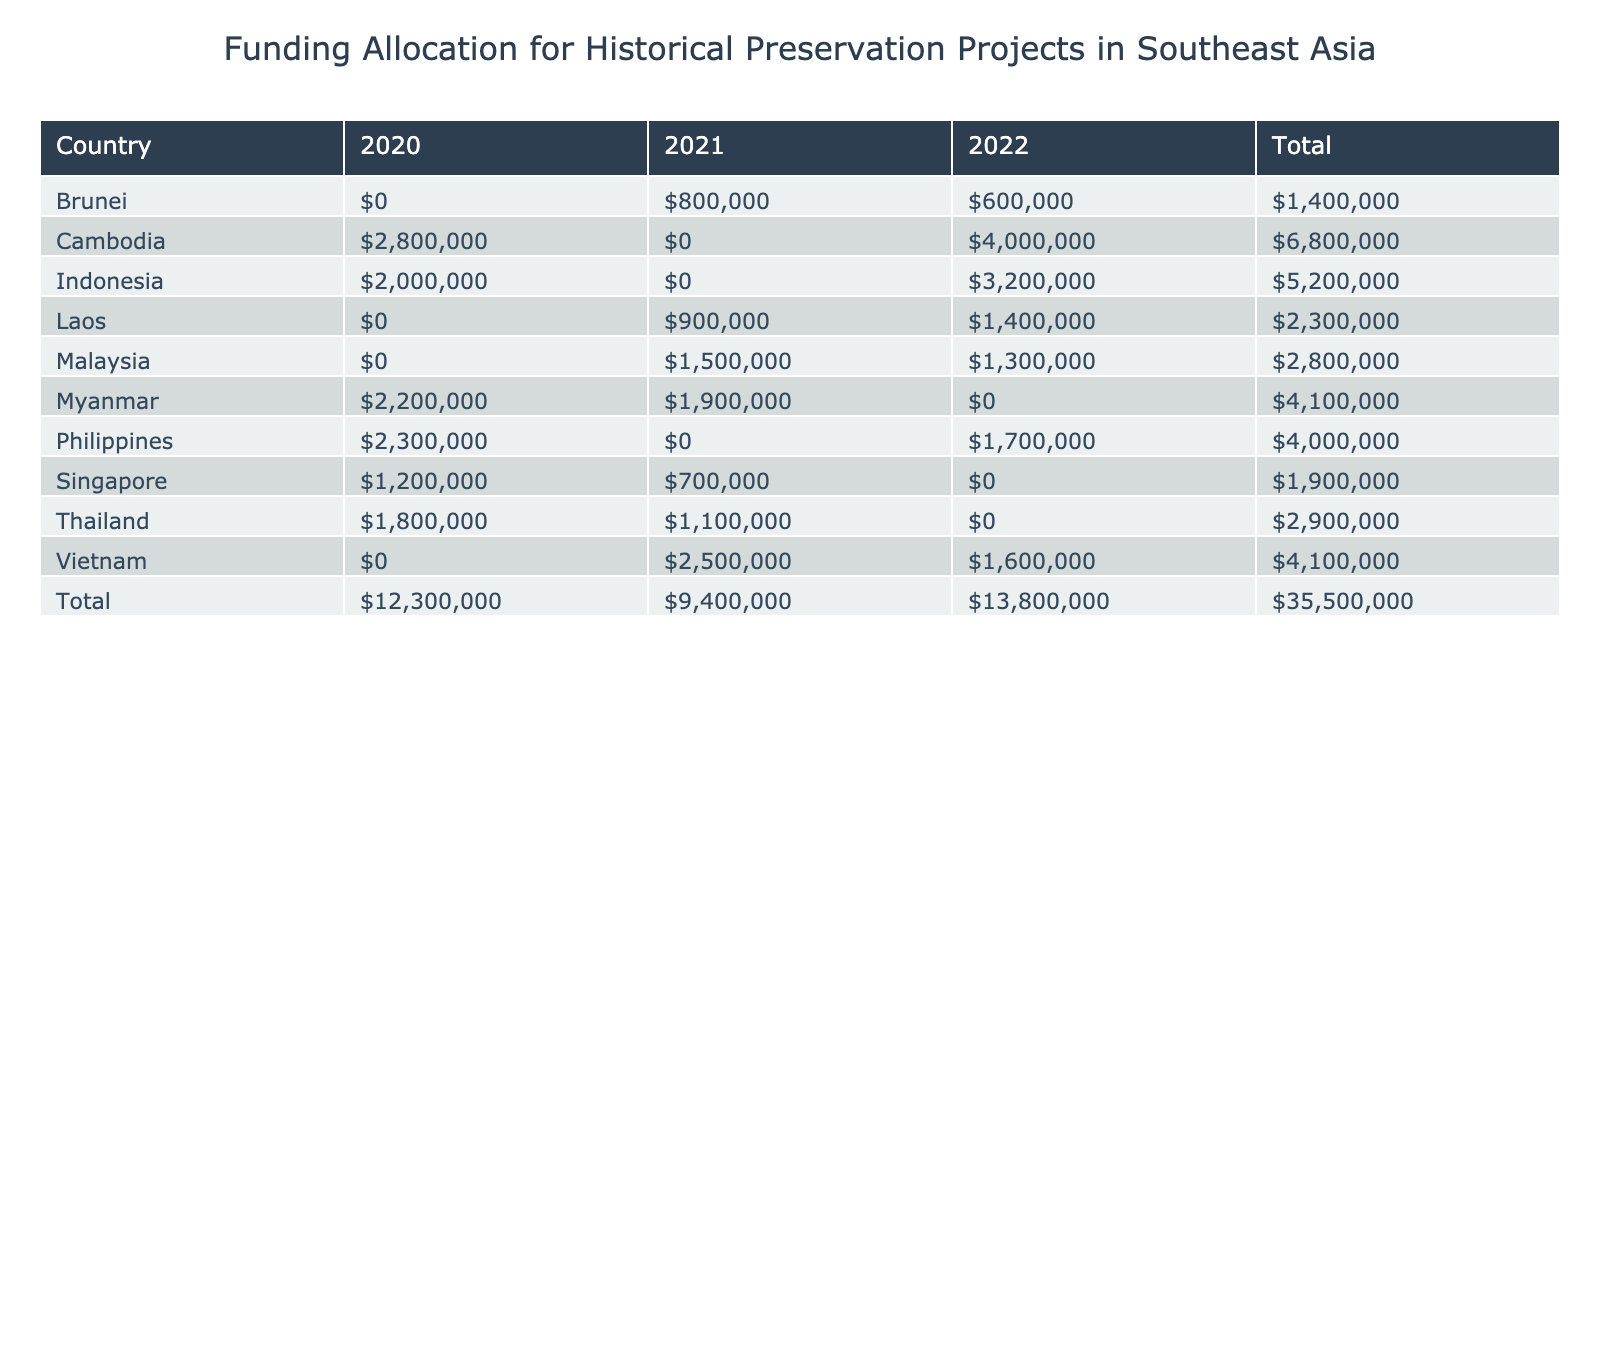What is the total funding allocated to historical preservation projects in Cambodia? The table shows two entries for Cambodia: Angkor Wat Structural Reinforcement with a funding of $4,000,000 in 2022 and Preah Vihear Temple Restoration with $2,800,000 in 2020. Summing these amounts gives us $4,000,000 + $2,800,000 = $6,800,000.
Answer: $6,800,000 Which country received the least funding in 2021? In 2021, there are six entries with the following funding amounts: Hue Imperial City Restoration (Vietnam) - $2,500,000, Mrauk U Archaeological Area Conservation (Myanmar) - $1,900,000, Plain of Jars Archaeological Study (Laos) - $900,000, Kampong Ayer Water Village Conservation (Brunei) - $800,000, Ban Chiang Archaeological Site Research (Thailand) - $1,100,000, and Fort Canning Heritage Trail Development (Singapore) - $700,000. Among these, the least is $700,000 for Fort Canning Heritage Trail Development.
Answer: Fort Canning Heritage Trail Development in Singapore Did any country receive funding for projects in both 2020 and 2022? Looking at the table, Indonesia appears twice: for Borobudur Temple Conservation in 2022 with $3,200,000, and Trowulan Ancient City Excavation in 2020 with $2,000,000. Since Indonesia has projects in both years, the answer is yes.
Answer: Yes What is the difference in total funding between Vietnam and Thailand? Vietnam has two entries: Hue Imperial City Restoration (2021) - $2,500,000 and My Son Sanctuary Reconstruction (2022) - $1,600,000. The total for Vietnam is $2,500,000 + $1,600,000 = $4,100,000. Thailand's projects are Ayutthaya Archaeological Research (2020) - $1,800,000 and Ban Chiang Archaeological Site Research (2021) - $1,100,000, giving a total of $1,800,000 + $1,100,000 = $2,900,000. The difference is $4,100,000 - $2,900,000 = $1,200,000.
Answer: $1,200,000 What percentage of the total funding for the Philippines does the Rice Terraces of Philippine Cordilleras Maintenance represent? The Rice Terraces of Philippine Cordilleras Maintenance funding is $2,300,000. The total funding for the Philippines includes Intramuros Colonial District Renovation ($1,700,000), making the total $2,300,000 + $1,700,000 = $4,000,000. To find the percentage, we calculate ($2,300,000 / $4,000,000) * 100 = 57.5%.
Answer: 57.5% 